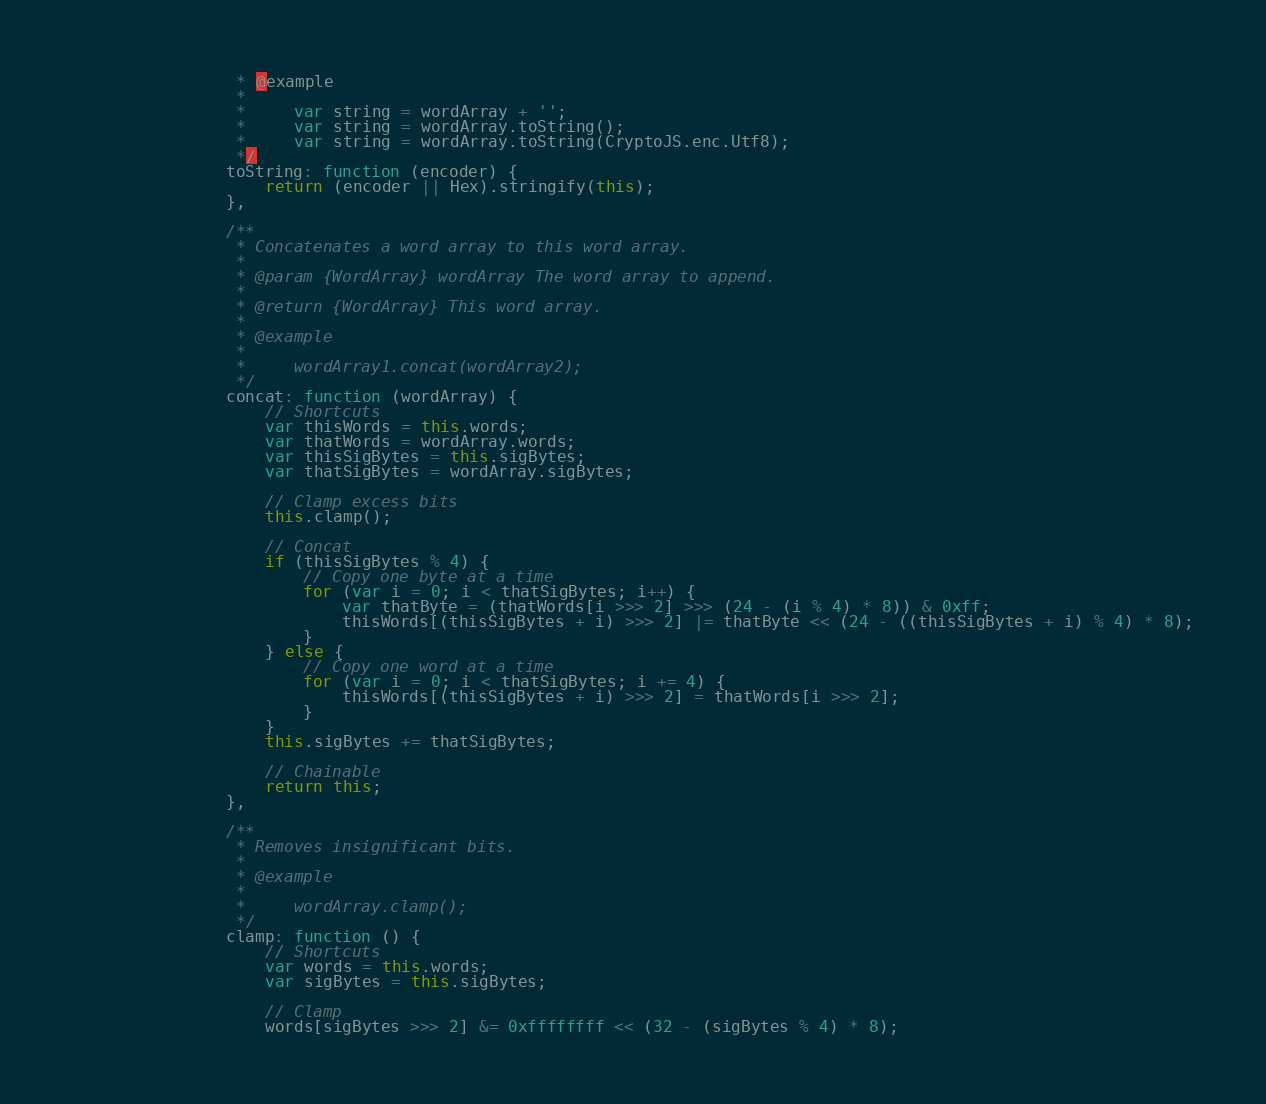Convert code to text. <code><loc_0><loc_0><loc_500><loc_500><_JavaScript_>    	         * @example
    	         *
    	         *     var string = wordArray + '';
    	         *     var string = wordArray.toString();
    	         *     var string = wordArray.toString(CryptoJS.enc.Utf8);
    	         */
    	        toString: function (encoder) {
    	            return (encoder || Hex).stringify(this);
    	        },

    	        /**
    	         * Concatenates a word array to this word array.
    	         *
    	         * @param {WordArray} wordArray The word array to append.
    	         *
    	         * @return {WordArray} This word array.
    	         *
    	         * @example
    	         *
    	         *     wordArray1.concat(wordArray2);
    	         */
    	        concat: function (wordArray) {
    	            // Shortcuts
    	            var thisWords = this.words;
    	            var thatWords = wordArray.words;
    	            var thisSigBytes = this.sigBytes;
    	            var thatSigBytes = wordArray.sigBytes;

    	            // Clamp excess bits
    	            this.clamp();

    	            // Concat
    	            if (thisSigBytes % 4) {
    	                // Copy one byte at a time
    	                for (var i = 0; i < thatSigBytes; i++) {
    	                    var thatByte = (thatWords[i >>> 2] >>> (24 - (i % 4) * 8)) & 0xff;
    	                    thisWords[(thisSigBytes + i) >>> 2] |= thatByte << (24 - ((thisSigBytes + i) % 4) * 8);
    	                }
    	            } else {
    	                // Copy one word at a time
    	                for (var i = 0; i < thatSigBytes; i += 4) {
    	                    thisWords[(thisSigBytes + i) >>> 2] = thatWords[i >>> 2];
    	                }
    	            }
    	            this.sigBytes += thatSigBytes;

    	            // Chainable
    	            return this;
    	        },

    	        /**
    	         * Removes insignificant bits.
    	         *
    	         * @example
    	         *
    	         *     wordArray.clamp();
    	         */
    	        clamp: function () {
    	            // Shortcuts
    	            var words = this.words;
    	            var sigBytes = this.sigBytes;

    	            // Clamp
    	            words[sigBytes >>> 2] &= 0xffffffff << (32 - (sigBytes % 4) * 8);</code> 